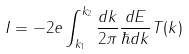<formula> <loc_0><loc_0><loc_500><loc_500>I = - 2 e \int _ { k _ { 1 } } ^ { k _ { 2 } } \frac { d k } { 2 \pi } \frac { d E } { \hbar { d } k } T ( k )</formula> 